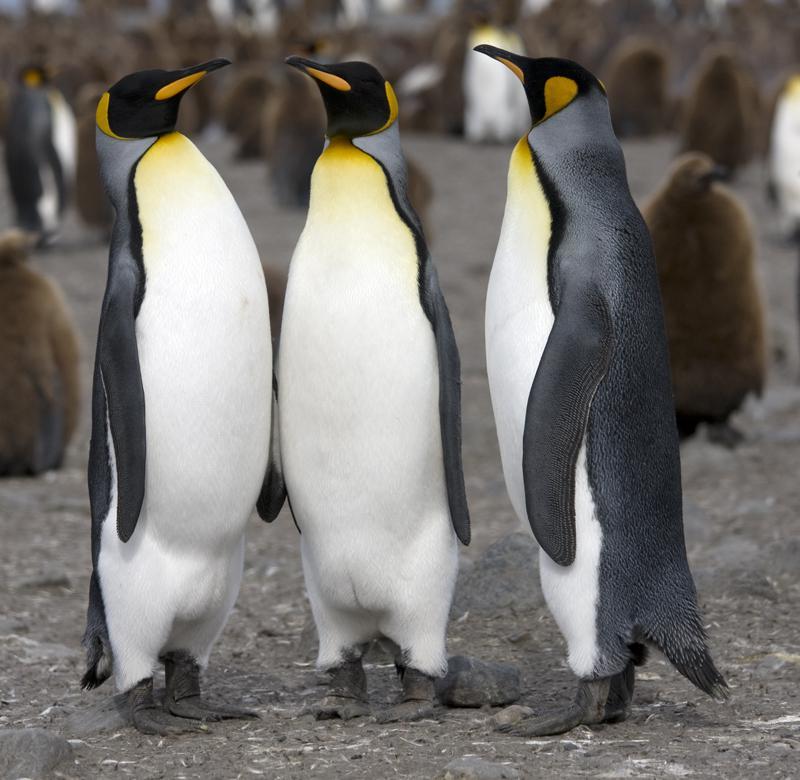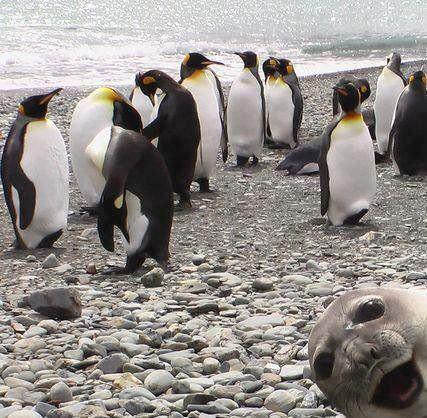The first image is the image on the left, the second image is the image on the right. For the images displayed, is the sentence "There is one seal on the ground in one of the images." factually correct? Answer yes or no. Yes. The first image is the image on the left, the second image is the image on the right. Examine the images to the left and right. Is the description "The ocean is visible." accurate? Answer yes or no. Yes. 